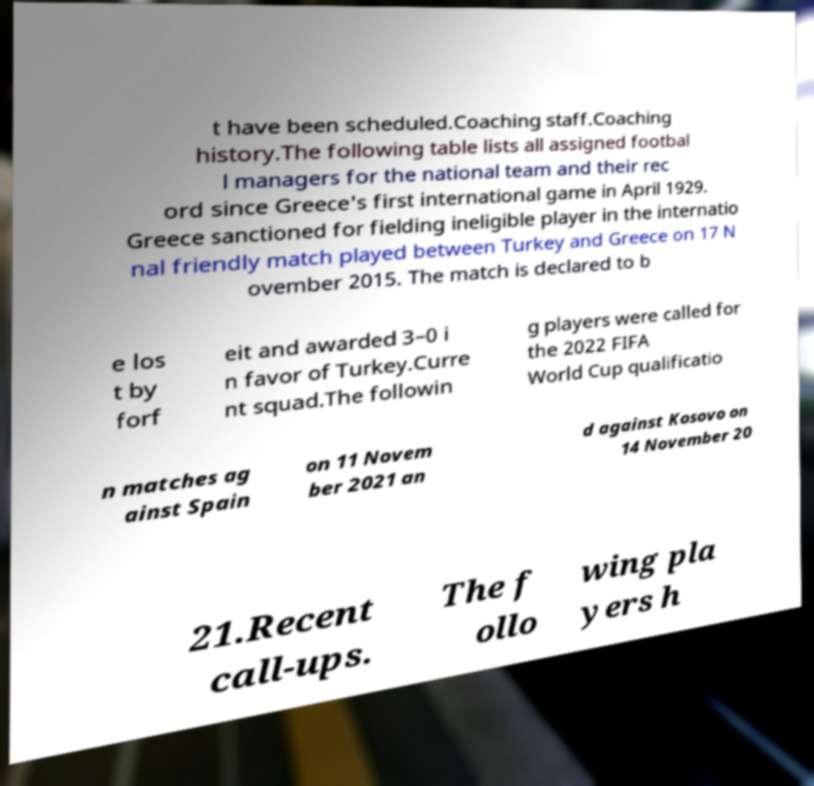There's text embedded in this image that I need extracted. Can you transcribe it verbatim? t have been scheduled.Coaching staff.Coaching history.The following table lists all assigned footbal l managers for the national team and their rec ord since Greece's first international game in April 1929. Greece sanctioned for fielding ineligible player in the internatio nal friendly match played between Turkey and Greece on 17 N ovember 2015. The match is declared to b e los t by forf eit and awarded 3–0 i n favor of Turkey.Curre nt squad.The followin g players were called for the 2022 FIFA World Cup qualificatio n matches ag ainst Spain on 11 Novem ber 2021 an d against Kosovo on 14 November 20 21.Recent call-ups. The f ollo wing pla yers h 